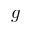<formula> <loc_0><loc_0><loc_500><loc_500>g</formula> 